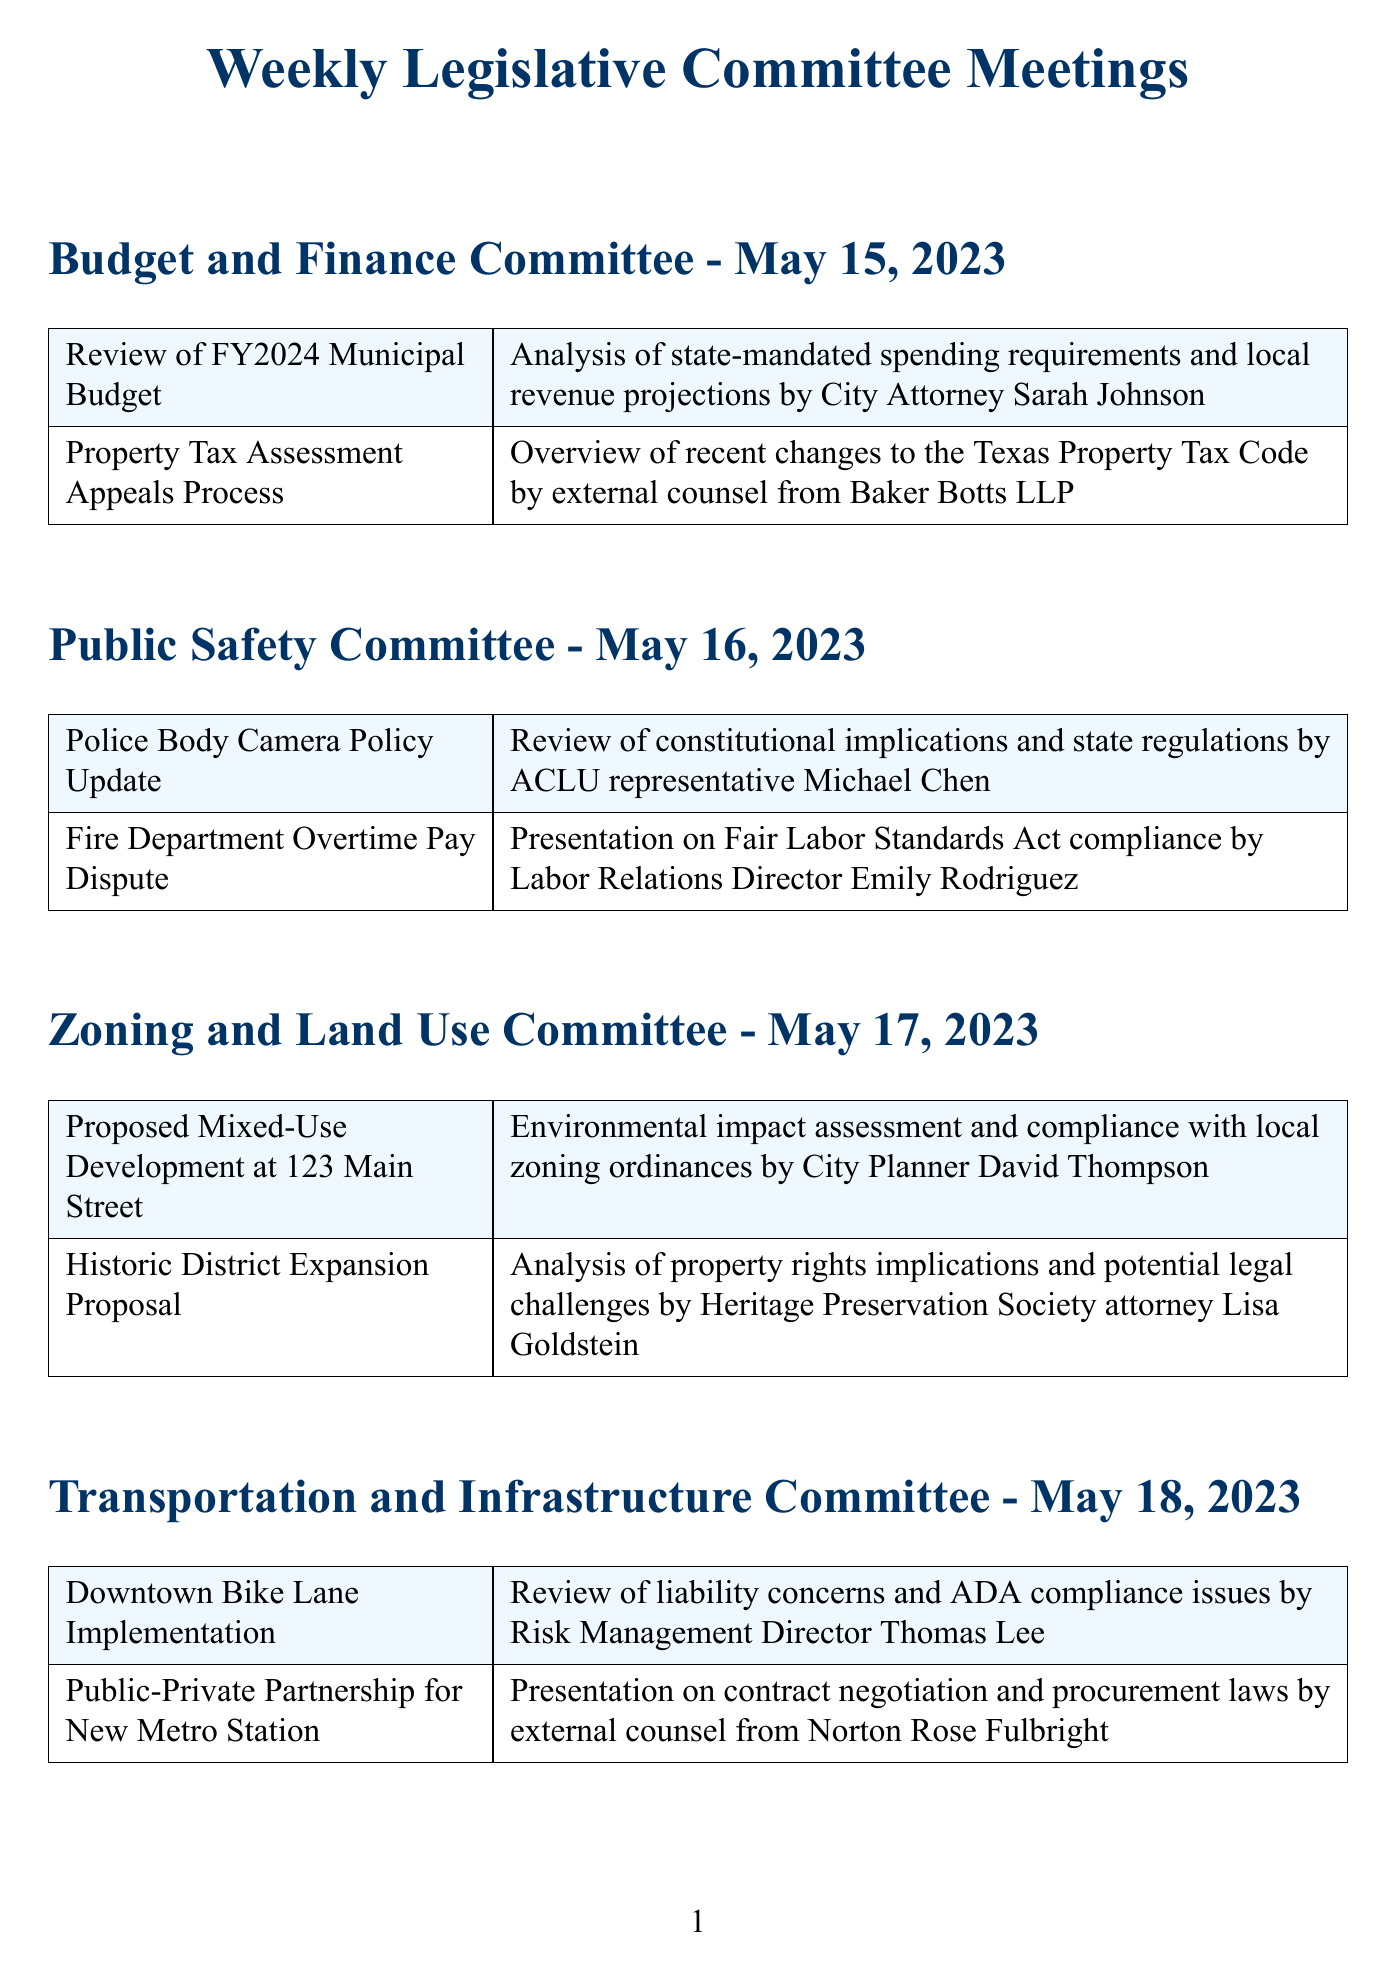What is the date of the Budget and Finance Committee meeting? The meeting is scheduled for May 15, 2023, as indicated at the beginning of that section.
Answer: May 15, 2023 Who presented the legal briefing on the COVID-19 Vaccination Program Update? The County Health Officer, Dr. Maria Sanchez, presented the legal briefing on that topic.
Answer: Dr. Maria Sanchez What is one of the agenda items discussed in the Transportation and Infrastructure Committee? The agenda item discussed was "Public-Private Partnership for New Metro Station", which is listed under that committee.
Answer: Public-Private Partnership for New Metro Station Which legal aspect was highlighted regarding the Proposed Mixed-Use Development at 123 Main Street? The legal briefing included an environmental impact assessment and compliance with local zoning ordinances, as noted in the document.
Answer: Environmental impact assessment and compliance with local zoning ordinances What is the primary focus of the legal briefing regarding the Fire Department Overtime Pay Dispute? The briefing is focused on Fair Labor Standards Act compliance, as mentioned in the agenda item description.
Answer: Fair Labor Standards Act compliance How many committees held meetings on May 17, 2023? The Zoning and Land Use Committee is the only committee that held a meeting on that date, which can be confirmed by reviewing the specified date.
Answer: One What is the title of the agenda item related to property tax? The agenda item is "Property Tax Assessment Appeals Process," as specified under the Budget and Finance Committee meeting.
Answer: Property Tax Assessment Appeals Process Who provided the legal briefing for the Police Body Camera Policy Update? The legal briefing was provided by ACLU representative Michael Chen, as listed in the agenda item details.
Answer: Michael Chen What type of compliance issues were discussed in the Downtown Bike Lane Implementation? The discussion included liability concerns and ADA compliance issues, according to the legal briefing provided in that section.
Answer: Liability concerns and ADA compliance issues 